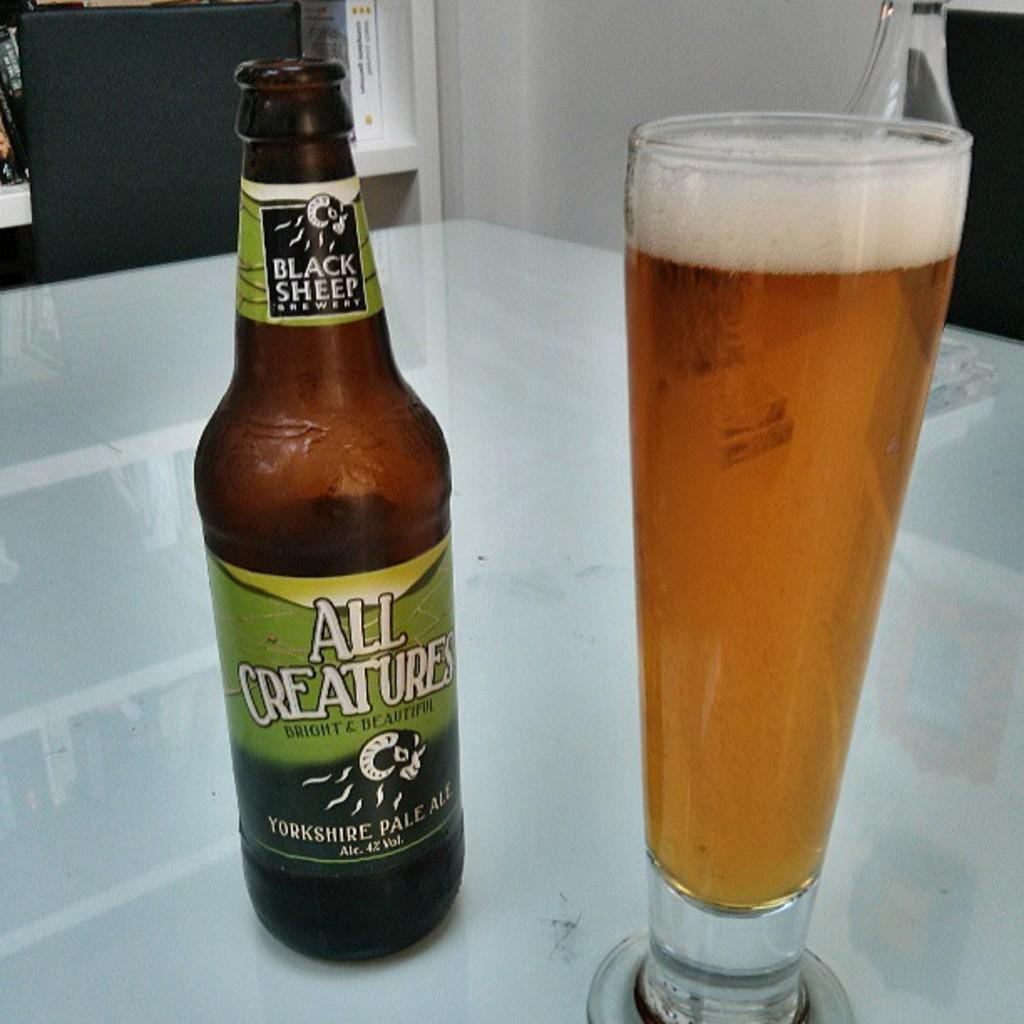Provide a one-sentence caption for the provided image. A bottle of All Creatures brand ale is next to a full glass. 